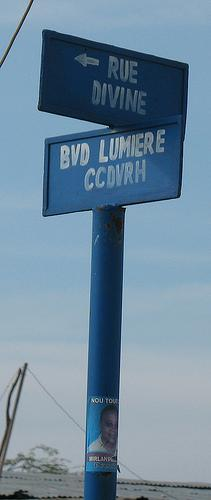Identify the color of the street signs and the color of the writing on them. The street signs are blue and the writing on them is white. Find an example of an object that has begun to show signs of aging or wear. There is a rusty area at the top of the blue pole. What is the main material of the pole supporting the street signs? The pole is made of metal. What is the main emotion expressed by the person in the image? The man is smiling. Are there any notable weather patterns, like a clear or hazy sky? The sky is very hazy. Briefly describe the image's overall sentiment or atmosphere. The image captures a hazy day with a street corner and blue street signs on a metal pole, with a smiling man and a picture of a woman. Are there any objects normally found in an urban environment, such as a power line or street corner? Yes, there is a street corner and a power line in the image. Count the total number of blue street signs in the image. There are two blue street signs. Provide a brief description of the picture found on the metal pole. The picture is of a woman with a blue background. Is there anything unusual or noteworthy about the top blue street sign? The top blue sign has an arrow and the text "rue" and "divine" on it. Is the street corner in the image green? No, it's not mentioned in the image. Is the sky extremely cloudy in the image? The instructions mention "the sky is very hazy" and "a clear sky," which implies that the sky is neither extremely cloudy nor completely clear. Does the pole have a red color on it? There is no mention of the color red for any objects in the image, including the pole. The pole is described as "the pole is blue" and "the pole is metal." Are the colors of the signs and the pole different from each other? Multiple captions reference the signs and the pole as blue, like "the thick blue pole," "the top blue sign," "the two blue signs." This suggests that both the signs and the pole have the same blue color. 